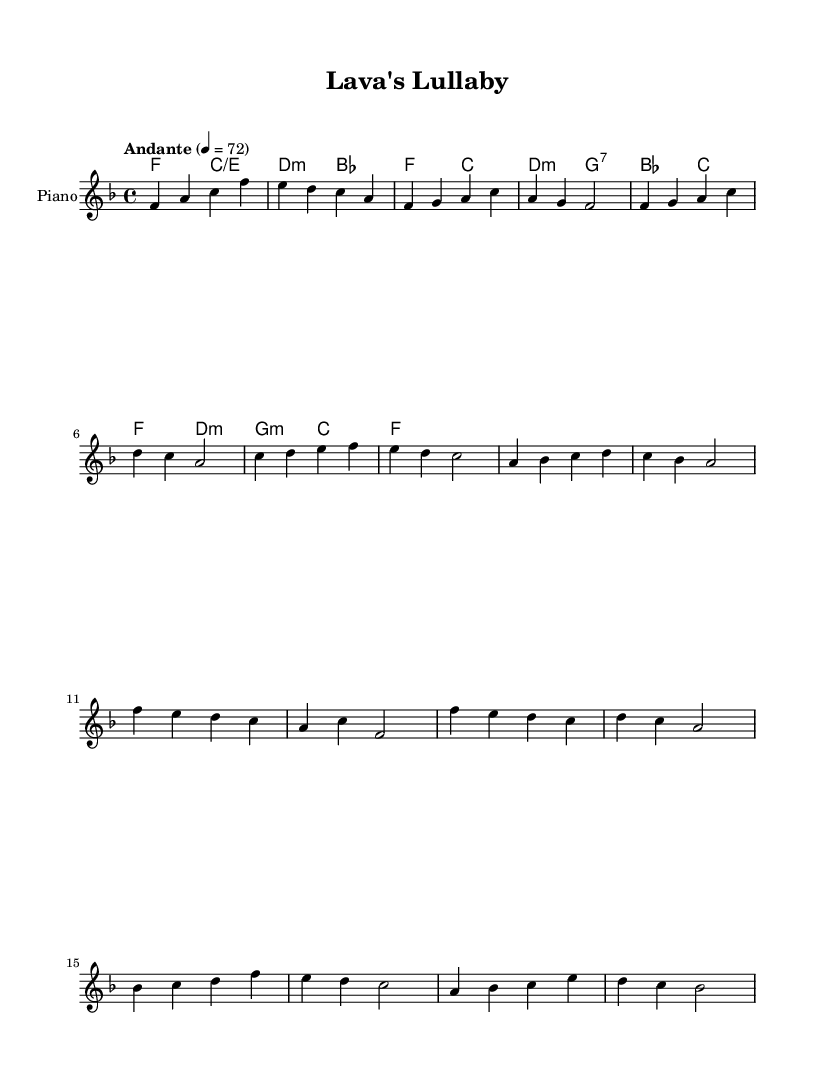What is the key signature of this music? The key signature is indicated by the number of sharps or flats in the beginning of the staff. In this case, there are no sharps or flats present, indicating the key of F major.
Answer: F major What is the time signature of this music? The time signature is located at the beginning of the piece. It is shown as 4/4, which means there are four beats in a measure and the quarter note gets one beat.
Answer: 4/4 What is the tempo marking of this piece? The tempo marking is typically found at the beginning after the time signature. Here, it states "Andante" with a metronome marking of 4 = 72, indicating a moderate pace.
Answer: Andante How many measures are in the chorus section? To determine the number of measures, we count each segment of the music within the chorus labeled segment. The chorus contains four measures in total.
Answer: 4 What type of harmonies are predominantly used in this piece? The harmonic section shows the chords being played, and we can categorize them. The piece predominantly uses major and minor chords, aligned with K-Pop ballad traditions, emphasizing emotional depth.
Answer: Major and minor Does the music include a bridge section? The presence of a bridge can be found by looking for a distinct change in the melody and chords compared to the verses and chorus. In this case, a bridge is present and can be identified by a varying sequence of notes and harmonies.
Answer: Yes Is the overall style of this piece reflective of typical K-Pop ballads? By analyzing the structure, emotional expression, and melodic content, we can see that K-Pop ballads often emphasize lyrical emotion, melodic beauty, and powerful choruses, which is consistent with this piece.
Answer: Yes 